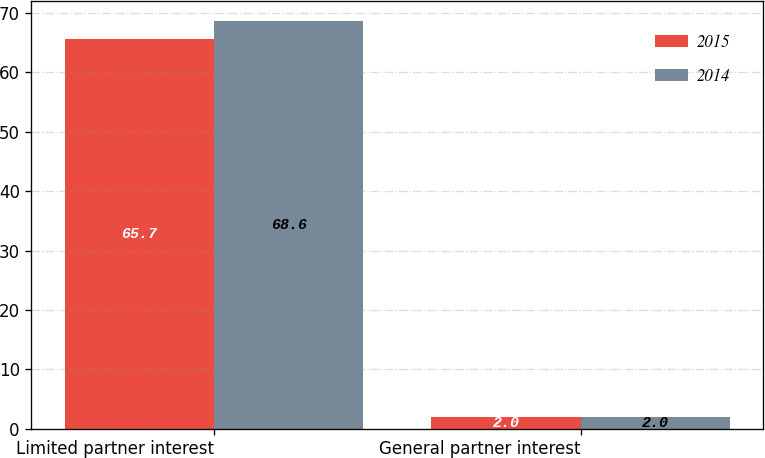Convert chart to OTSL. <chart><loc_0><loc_0><loc_500><loc_500><stacked_bar_chart><ecel><fcel>Limited partner interest<fcel>General partner interest<nl><fcel>2015<fcel>65.7<fcel>2<nl><fcel>2014<fcel>68.6<fcel>2<nl></chart> 